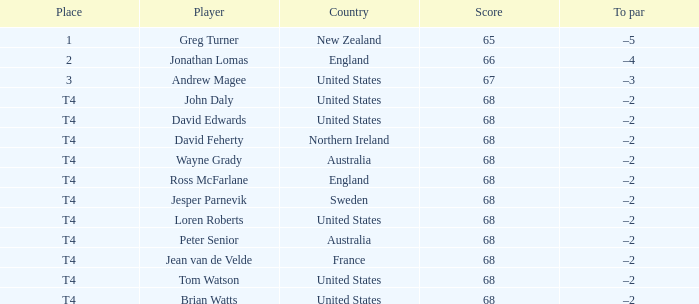Write the full table. {'header': ['Place', 'Player', 'Country', 'Score', 'To par'], 'rows': [['1', 'Greg Turner', 'New Zealand', '65', '–5'], ['2', 'Jonathan Lomas', 'England', '66', '–4'], ['3', 'Andrew Magee', 'United States', '67', '–3'], ['T4', 'John Daly', 'United States', '68', '–2'], ['T4', 'David Edwards', 'United States', '68', '–2'], ['T4', 'David Feherty', 'Northern Ireland', '68', '–2'], ['T4', 'Wayne Grady', 'Australia', '68', '–2'], ['T4', 'Ross McFarlane', 'England', '68', '–2'], ['T4', 'Jesper Parnevik', 'Sweden', '68', '–2'], ['T4', 'Loren Roberts', 'United States', '68', '–2'], ['T4', 'Peter Senior', 'Australia', '68', '–2'], ['T4', 'Jean van de Velde', 'France', '68', '–2'], ['T4', 'Tom Watson', 'United States', '68', '–2'], ['T4', 'Brian Watts', 'United States', '68', '–2']]} What is the place in england with a score greater than 66? T4. 